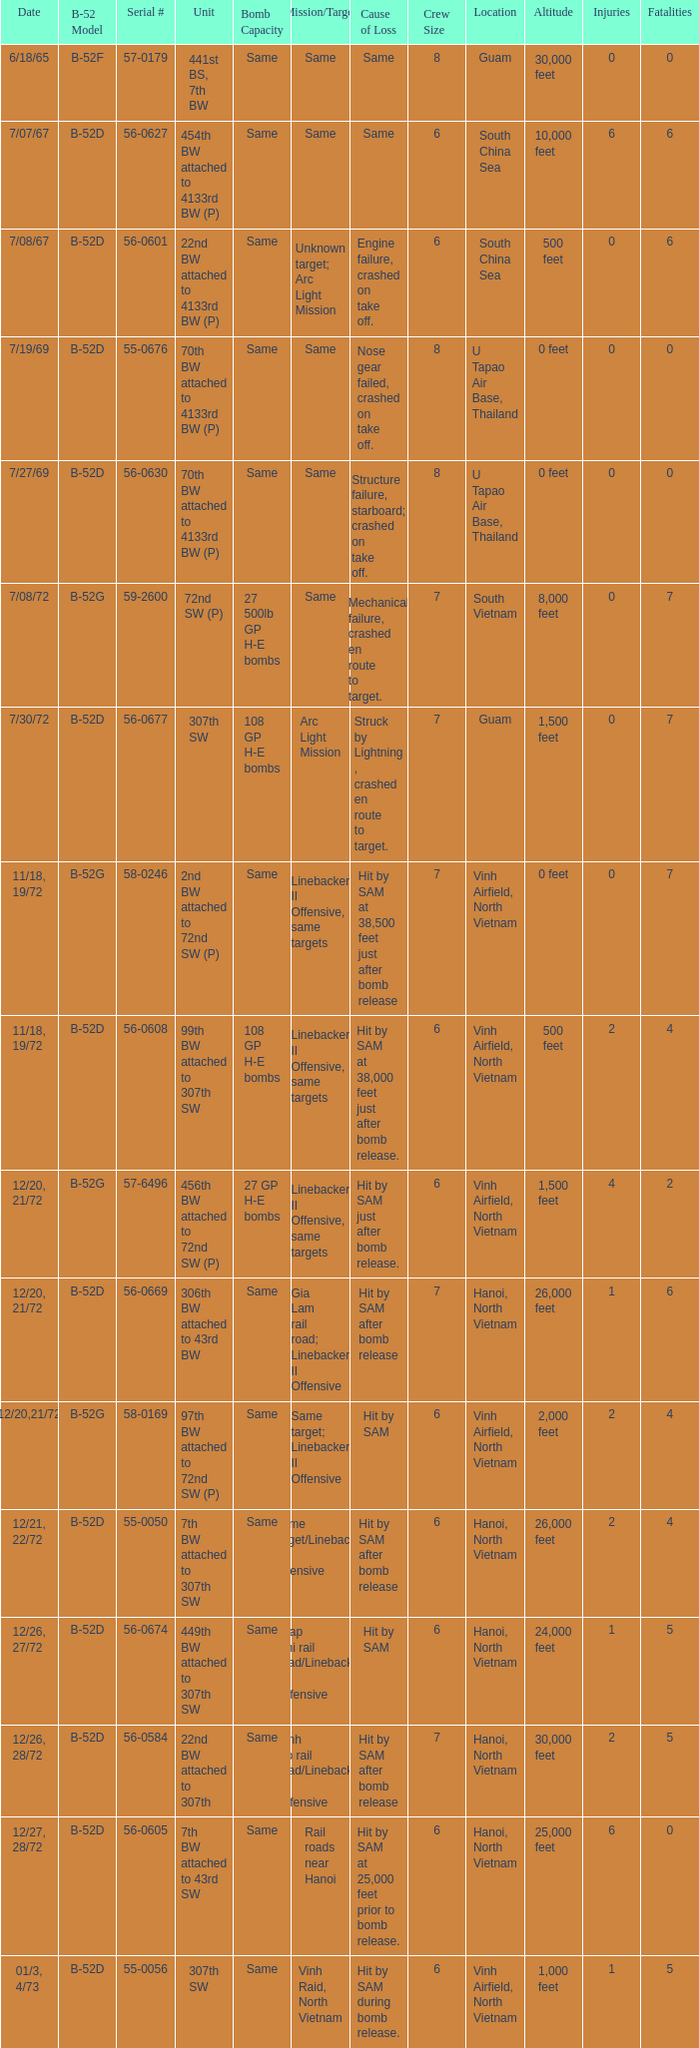When 441st bs, 7th bw is the unit what is the b-52 model? B-52F. 